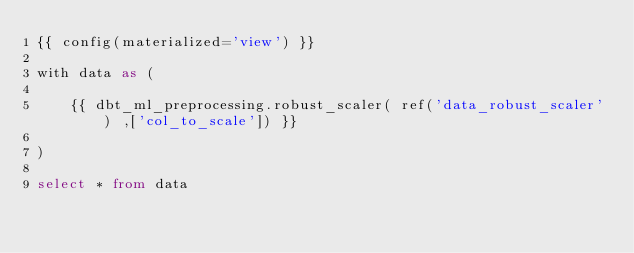<code> <loc_0><loc_0><loc_500><loc_500><_SQL_>{{ config(materialized='view') }}

with data as (

    {{ dbt_ml_preprocessing.robust_scaler( ref('data_robust_scaler') ,['col_to_scale']) }}

)

select * from data
</code> 